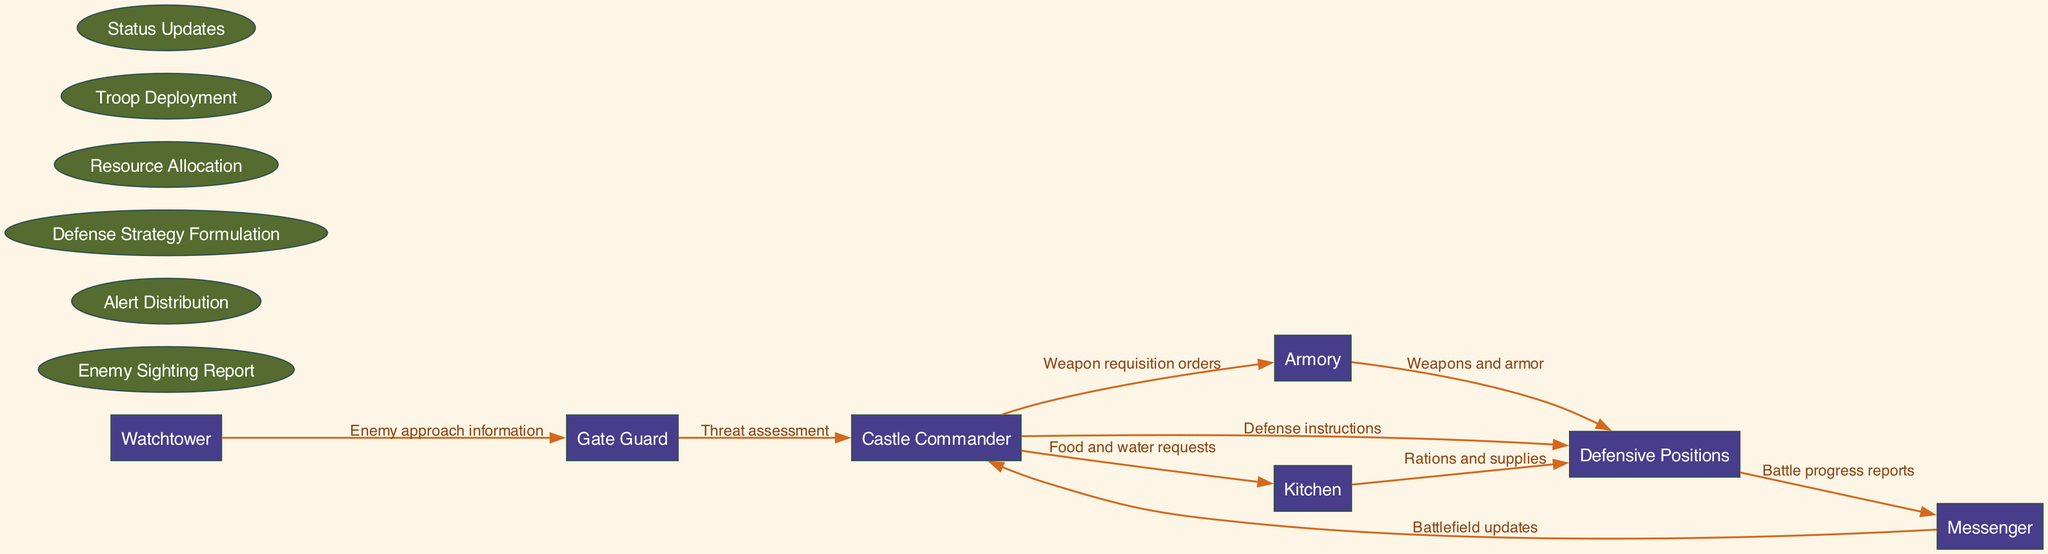What is the first entity that provides information about enemy approach? The diagram shows the Watchtower as the initial entity involved in reporting enemy sighting information to the Gate Guard.
Answer: Watchtower Which node receives the threat assessment? According to the diagram, the entity that receives the threat assessment from the Gate Guard is the Castle Commander.
Answer: Castle Commander How many processes are listed in the diagram? The diagram enumerates six distinct processes, which are listed in the 'processes' section of the data provided.
Answer: Six What is the label of the flow from the Armory to Defensive Positions? The diagram shows that the label for the flow from the Armory to Defensive Positions is "Weapons and armor."
Answer: Weapons and armor Which two entities communicate through "Battle progress reports"? The diagram indicates that the Defensive Positions send "Battle progress reports" to the Messenger, establishing a link between these two entities.
Answer: Defensive Positions, Messenger What does the Castle Commander send to the Kitchen? From the diagram, the Castle Commander sends "Food and water requests" to the Kitchen, showing the need for supplies during the siege.
Answer: Food and water requests Which node has the responsibility for troop deployment? The diagram suggests that the Castle Commander is responsible for the process of troop deployment as part of the defense strategy.
Answer: Castle Commander What is the final destination of the rations and supplies? The diagram calculates that the rations and supplies flow from the Kitchen to the Defensive Positions, indicating where they are ultimately used.
Answer: Defensive Positions How many edges connect the entities in the diagram? By examining the diagram, one can count a total of eight distinct edges that connect the specified entities.
Answer: Eight 